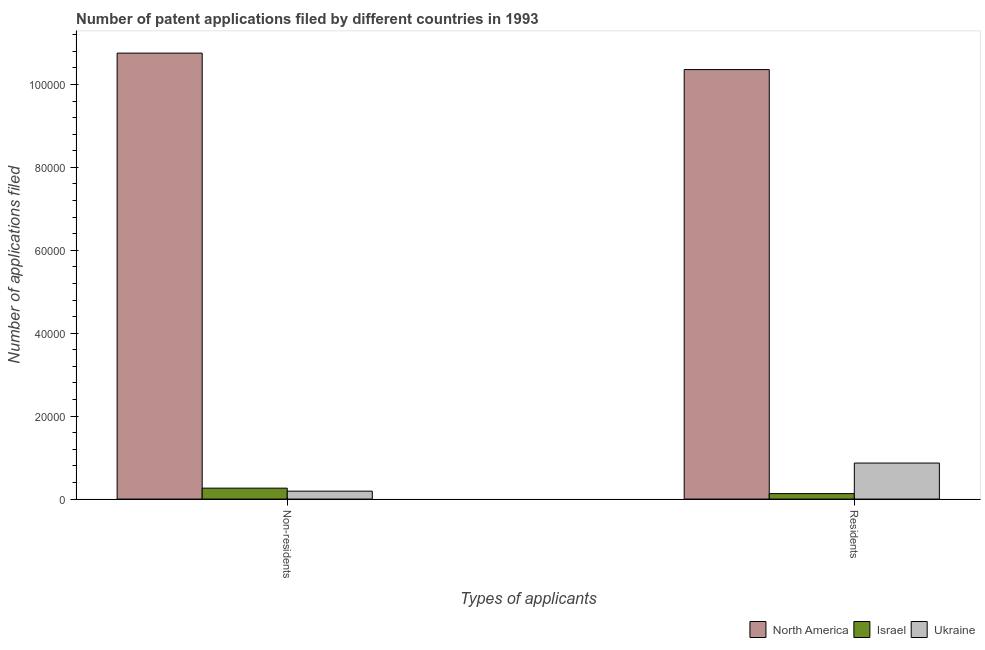How many different coloured bars are there?
Keep it short and to the point. 3. How many groups of bars are there?
Provide a short and direct response. 2. Are the number of bars per tick equal to the number of legend labels?
Your answer should be very brief. Yes. How many bars are there on the 1st tick from the right?
Your answer should be very brief. 3. What is the label of the 1st group of bars from the left?
Your answer should be compact. Non-residents. What is the number of patent applications by non residents in Israel?
Offer a very short reply. 2635. Across all countries, what is the maximum number of patent applications by residents?
Offer a terse response. 1.04e+05. Across all countries, what is the minimum number of patent applications by residents?
Offer a terse response. 1318. In which country was the number of patent applications by non residents maximum?
Offer a terse response. North America. In which country was the number of patent applications by non residents minimum?
Keep it short and to the point. Ukraine. What is the total number of patent applications by residents in the graph?
Offer a very short reply. 1.14e+05. What is the difference between the number of patent applications by residents in Israel and that in North America?
Offer a terse response. -1.02e+05. What is the difference between the number of patent applications by non residents in Ukraine and the number of patent applications by residents in North America?
Your response must be concise. -1.02e+05. What is the average number of patent applications by non residents per country?
Offer a terse response. 3.74e+04. What is the difference between the number of patent applications by residents and number of patent applications by non residents in Israel?
Keep it short and to the point. -1317. What is the ratio of the number of patent applications by non residents in Israel to that in Ukraine?
Your answer should be compact. 1.38. Is the number of patent applications by non residents in Ukraine less than that in Israel?
Provide a short and direct response. Yes. What does the 3rd bar from the left in Non-residents represents?
Ensure brevity in your answer.  Ukraine. Are all the bars in the graph horizontal?
Your answer should be compact. No. What is the difference between two consecutive major ticks on the Y-axis?
Give a very brief answer. 2.00e+04. Are the values on the major ticks of Y-axis written in scientific E-notation?
Make the answer very short. No. Does the graph contain grids?
Provide a short and direct response. No. Where does the legend appear in the graph?
Ensure brevity in your answer.  Bottom right. How many legend labels are there?
Your answer should be very brief. 3. How are the legend labels stacked?
Your answer should be compact. Horizontal. What is the title of the graph?
Your response must be concise. Number of patent applications filed by different countries in 1993. What is the label or title of the X-axis?
Offer a terse response. Types of applicants. What is the label or title of the Y-axis?
Keep it short and to the point. Number of applications filed. What is the Number of applications filed in North America in Non-residents?
Offer a very short reply. 1.08e+05. What is the Number of applications filed of Israel in Non-residents?
Your answer should be very brief. 2635. What is the Number of applications filed in Ukraine in Non-residents?
Offer a terse response. 1909. What is the Number of applications filed of North America in Residents?
Your answer should be compact. 1.04e+05. What is the Number of applications filed in Israel in Residents?
Provide a succinct answer. 1318. What is the Number of applications filed of Ukraine in Residents?
Make the answer very short. 8687. Across all Types of applicants, what is the maximum Number of applications filed in North America?
Make the answer very short. 1.08e+05. Across all Types of applicants, what is the maximum Number of applications filed of Israel?
Make the answer very short. 2635. Across all Types of applicants, what is the maximum Number of applications filed of Ukraine?
Offer a very short reply. 8687. Across all Types of applicants, what is the minimum Number of applications filed in North America?
Ensure brevity in your answer.  1.04e+05. Across all Types of applicants, what is the minimum Number of applications filed in Israel?
Your response must be concise. 1318. Across all Types of applicants, what is the minimum Number of applications filed in Ukraine?
Your answer should be compact. 1909. What is the total Number of applications filed in North America in the graph?
Offer a terse response. 2.11e+05. What is the total Number of applications filed of Israel in the graph?
Your answer should be compact. 3953. What is the total Number of applications filed of Ukraine in the graph?
Ensure brevity in your answer.  1.06e+04. What is the difference between the Number of applications filed of North America in Non-residents and that in Residents?
Make the answer very short. 3970. What is the difference between the Number of applications filed in Israel in Non-residents and that in Residents?
Make the answer very short. 1317. What is the difference between the Number of applications filed in Ukraine in Non-residents and that in Residents?
Ensure brevity in your answer.  -6778. What is the difference between the Number of applications filed in North America in Non-residents and the Number of applications filed in Israel in Residents?
Make the answer very short. 1.06e+05. What is the difference between the Number of applications filed of North America in Non-residents and the Number of applications filed of Ukraine in Residents?
Offer a very short reply. 9.89e+04. What is the difference between the Number of applications filed in Israel in Non-residents and the Number of applications filed in Ukraine in Residents?
Make the answer very short. -6052. What is the average Number of applications filed in North America per Types of applicants?
Your answer should be compact. 1.06e+05. What is the average Number of applications filed of Israel per Types of applicants?
Offer a terse response. 1976.5. What is the average Number of applications filed of Ukraine per Types of applicants?
Ensure brevity in your answer.  5298. What is the difference between the Number of applications filed of North America and Number of applications filed of Israel in Non-residents?
Offer a terse response. 1.05e+05. What is the difference between the Number of applications filed of North America and Number of applications filed of Ukraine in Non-residents?
Your response must be concise. 1.06e+05. What is the difference between the Number of applications filed in Israel and Number of applications filed in Ukraine in Non-residents?
Your answer should be compact. 726. What is the difference between the Number of applications filed of North America and Number of applications filed of Israel in Residents?
Make the answer very short. 1.02e+05. What is the difference between the Number of applications filed of North America and Number of applications filed of Ukraine in Residents?
Your response must be concise. 9.49e+04. What is the difference between the Number of applications filed of Israel and Number of applications filed of Ukraine in Residents?
Keep it short and to the point. -7369. What is the ratio of the Number of applications filed of North America in Non-residents to that in Residents?
Offer a very short reply. 1.04. What is the ratio of the Number of applications filed in Israel in Non-residents to that in Residents?
Your response must be concise. 2. What is the ratio of the Number of applications filed of Ukraine in Non-residents to that in Residents?
Your answer should be very brief. 0.22. What is the difference between the highest and the second highest Number of applications filed in North America?
Provide a succinct answer. 3970. What is the difference between the highest and the second highest Number of applications filed in Israel?
Your answer should be compact. 1317. What is the difference between the highest and the second highest Number of applications filed of Ukraine?
Ensure brevity in your answer.  6778. What is the difference between the highest and the lowest Number of applications filed of North America?
Ensure brevity in your answer.  3970. What is the difference between the highest and the lowest Number of applications filed in Israel?
Keep it short and to the point. 1317. What is the difference between the highest and the lowest Number of applications filed of Ukraine?
Give a very brief answer. 6778. 